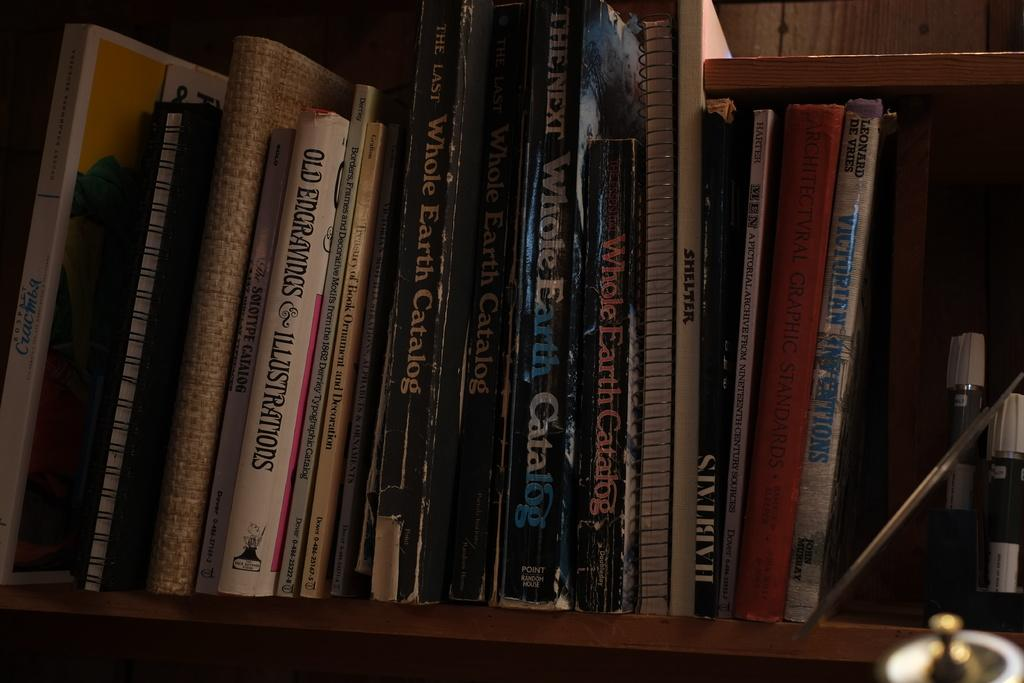<image>
Give a short and clear explanation of the subsequent image. a few books with one that has the word whole on it 